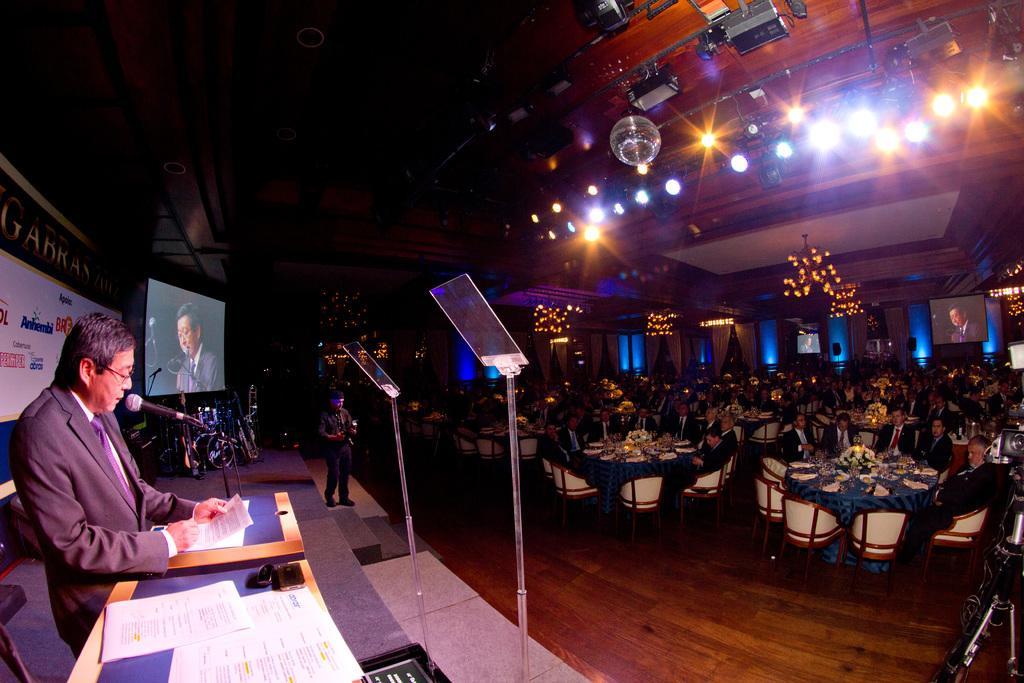Please provide a concise description of this image. This image is taken in an auditorium, there are many people in this auditorium. In the right side of the image a man standing in front of podium, holding papers in his hand. There is a screen, there is mic. In the middle of the image there are chandeliers on the roof, there are lamps. In the left side, right side of the image there is a table and a flower vase on the table. There are many chairs. There is a camera in the right side of the image. 